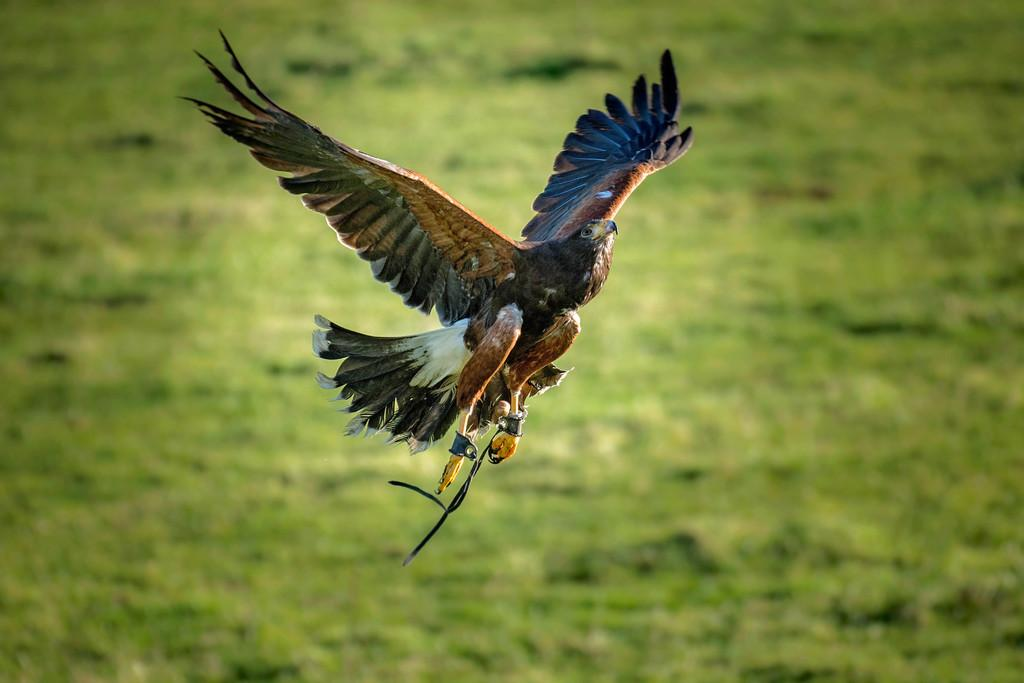What is the main subject of the image? There is a bird flying in the image. What can be seen in the background of the image? There is grass visible in the background of the image. What color is the crayon used to draw the bird in the image? There is no crayon or drawing present in the image; it is a photograph of a real bird flying. 